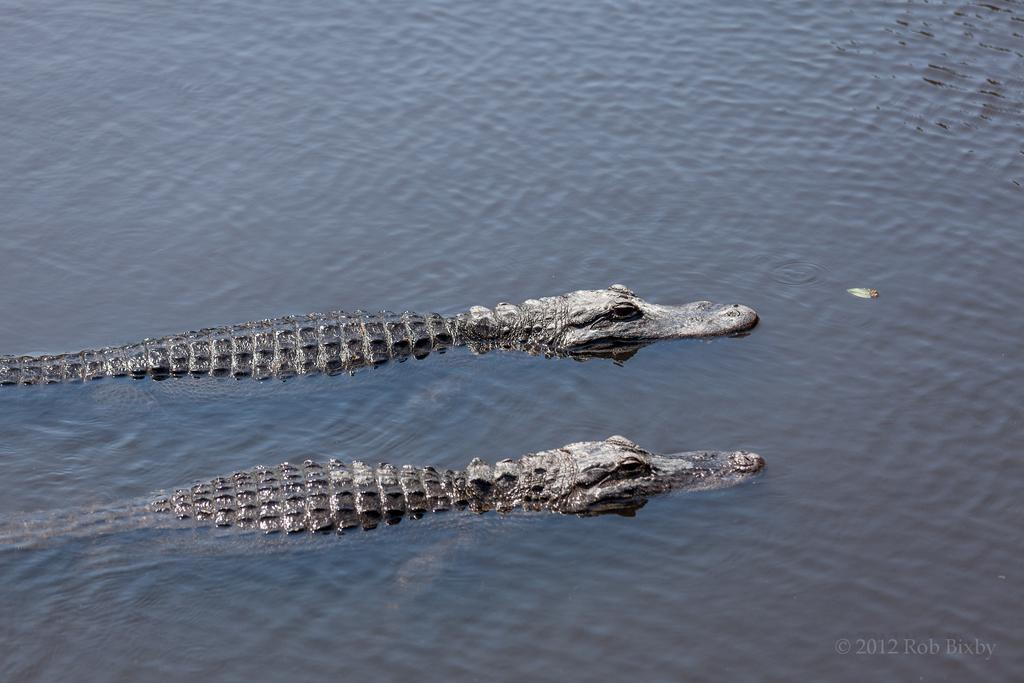What is the primary element visible in the image? There is water in the image. What is the color of the water in the image? The water appears to be black in color. What type of animals can be seen on the surface of the water? There are two reptiles on the surface of the water. What is the color of the reptiles in the image? The reptiles are black and ash in color. Can you see a fork in the water in the image? There is no fork present in the image; it features water with two reptiles on the surface. Is there a yak swimming in the water in the image? There is no yak present in the image; it features water with two reptiles on the surface. 